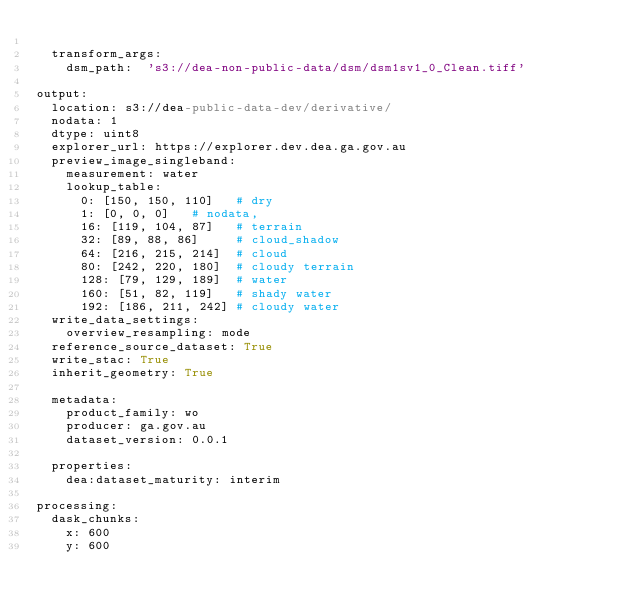<code> <loc_0><loc_0><loc_500><loc_500><_YAML_>
  transform_args:
    dsm_path:  's3://dea-non-public-data/dsm/dsm1sv1_0_Clean.tiff'

output:
  location: s3://dea-public-data-dev/derivative/
  nodata: 1
  dtype: uint8
  explorer_url: https://explorer.dev.dea.ga.gov.au
  preview_image_singleband:
    measurement: water
    lookup_table:
      0: [150, 150, 110]   # dry
      1: [0, 0, 0]   # nodata,
      16: [119, 104, 87]   # terrain
      32: [89, 88, 86]     # cloud_shadow
      64: [216, 215, 214]  # cloud
      80: [242, 220, 180]  # cloudy terrain
      128: [79, 129, 189]  # water
      160: [51, 82, 119]   # shady water
      192: [186, 211, 242] # cloudy water
  write_data_settings:
    overview_resampling: mode
  reference_source_dataset: True
  write_stac: True
  inherit_geometry: True

  metadata:
    product_family: wo
    producer: ga.gov.au
    dataset_version: 0.0.1

  properties:
    dea:dataset_maturity: interim

processing:
  dask_chunks:
    x: 600
    y: 600
</code> 